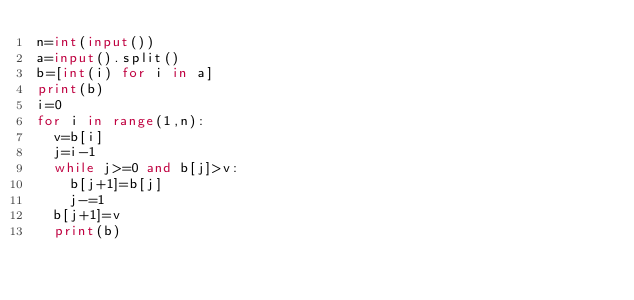Convert code to text. <code><loc_0><loc_0><loc_500><loc_500><_Python_>n=int(input())
a=input().split()
b=[int(i) for i in a]
print(b)
i=0
for i in range(1,n):
  v=b[i]
  j=i-1
  while j>=0 and b[j]>v:
    b[j+1]=b[j]
    j-=1
  b[j+1]=v
  print(b)
  
</code> 